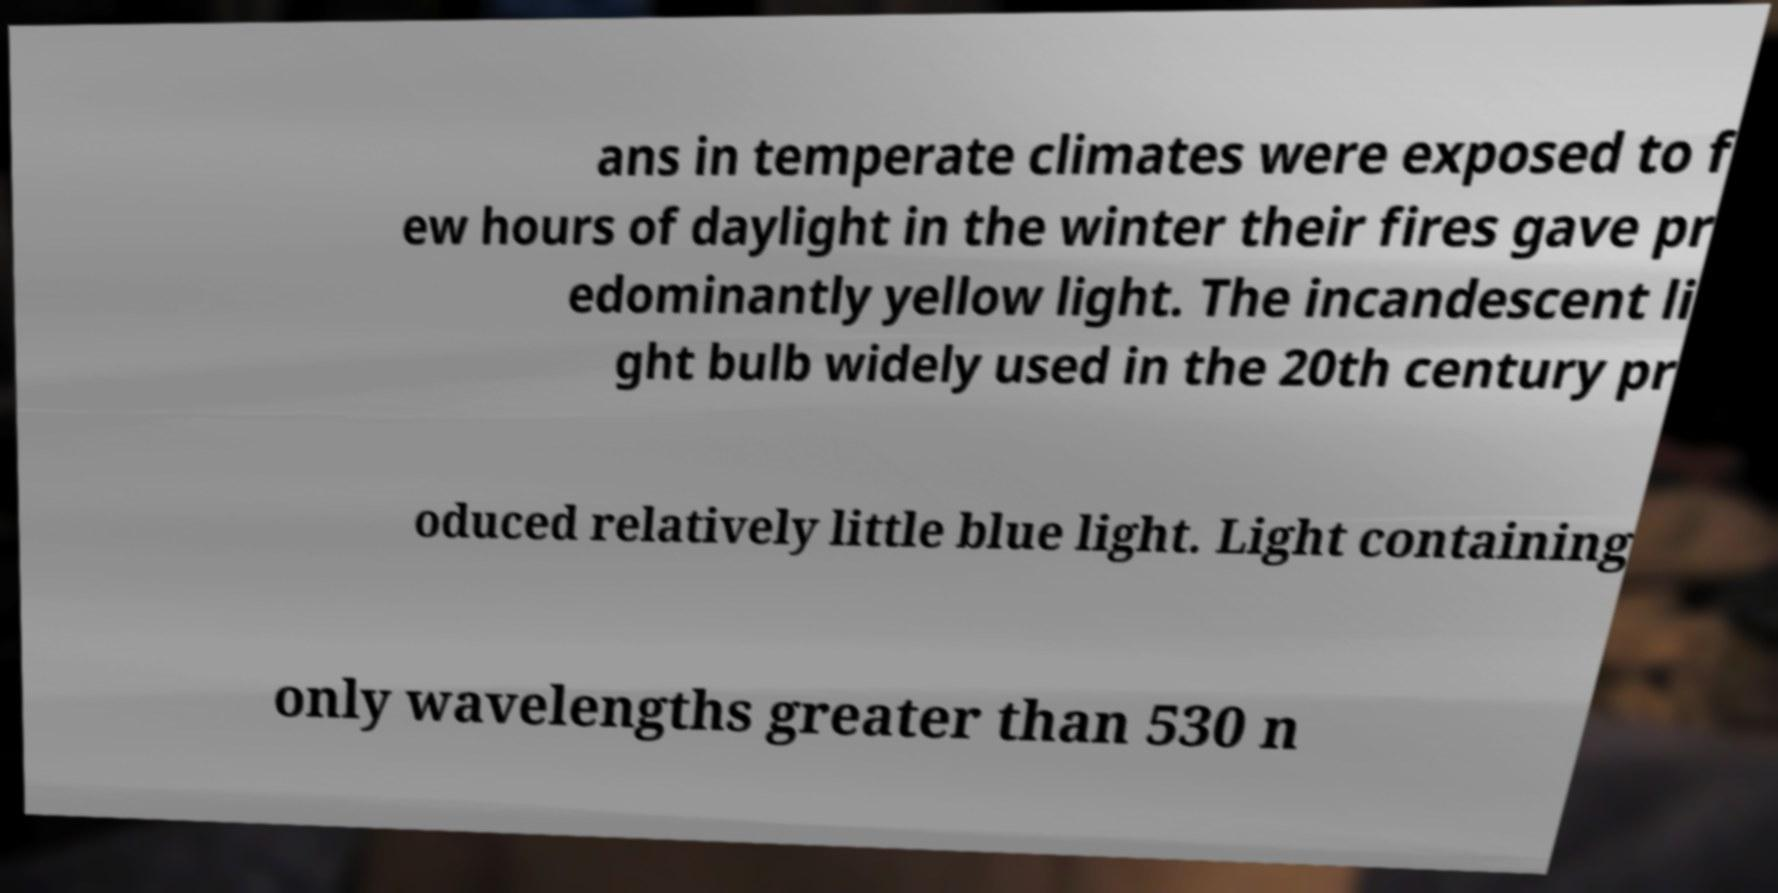There's text embedded in this image that I need extracted. Can you transcribe it verbatim? ans in temperate climates were exposed to f ew hours of daylight in the winter their fires gave pr edominantly yellow light. The incandescent li ght bulb widely used in the 20th century pr oduced relatively little blue light. Light containing only wavelengths greater than 530 n 